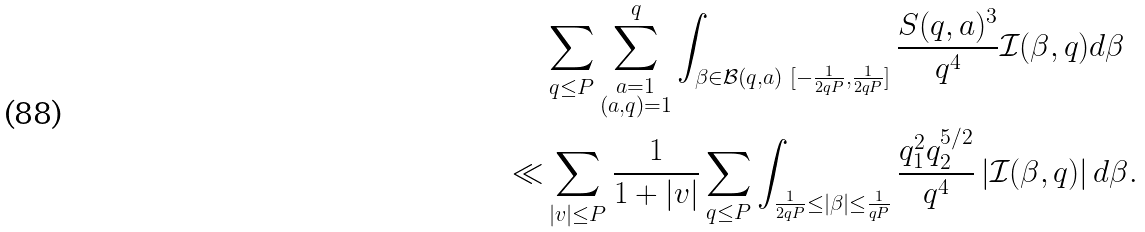Convert formula to latex. <formula><loc_0><loc_0><loc_500><loc_500>& \sum _ { q \leq P } \sum _ { \substack { a = 1 \\ ( a , q ) = 1 } } ^ { q } \int _ { \beta \in \mathcal { B } ( q , a ) \ [ - \frac { 1 } { 2 q P } , \frac { 1 } { 2 q P } ] } \frac { S ( q , a ) ^ { 3 } } { q ^ { 4 } } \mathcal { I } ( \beta , q ) d \beta \\ \ll & \sum _ { | v | \leq P } \frac { 1 } { 1 + | v | } \sum _ { q \leq P } \int _ { \frac { 1 } { 2 q P } \leq | \beta | \leq \frac { 1 } { q P } } \frac { q _ { 1 } ^ { 2 } q _ { 2 } ^ { 5 / 2 } } { q ^ { 4 } } \left | \mathcal { I } ( \beta , q ) \right | d \beta .</formula> 